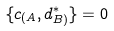<formula> <loc_0><loc_0><loc_500><loc_500>\{ c _ { ( A } , d ^ { * } _ { B ) } \} = 0</formula> 